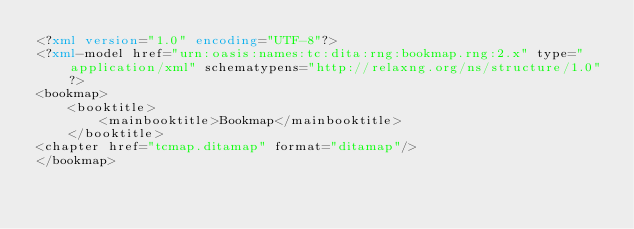<code> <loc_0><loc_0><loc_500><loc_500><_XML_><?xml version="1.0" encoding="UTF-8"?>
<?xml-model href="urn:oasis:names:tc:dita:rng:bookmap.rng:2.x" type="application/xml" schematypens="http://relaxng.org/ns/structure/1.0"?>
<bookmap>
    <booktitle>
        <mainbooktitle>Bookmap</mainbooktitle>
    </booktitle>
<chapter href="tcmap.ditamap" format="ditamap"/>
</bookmap>
</code> 